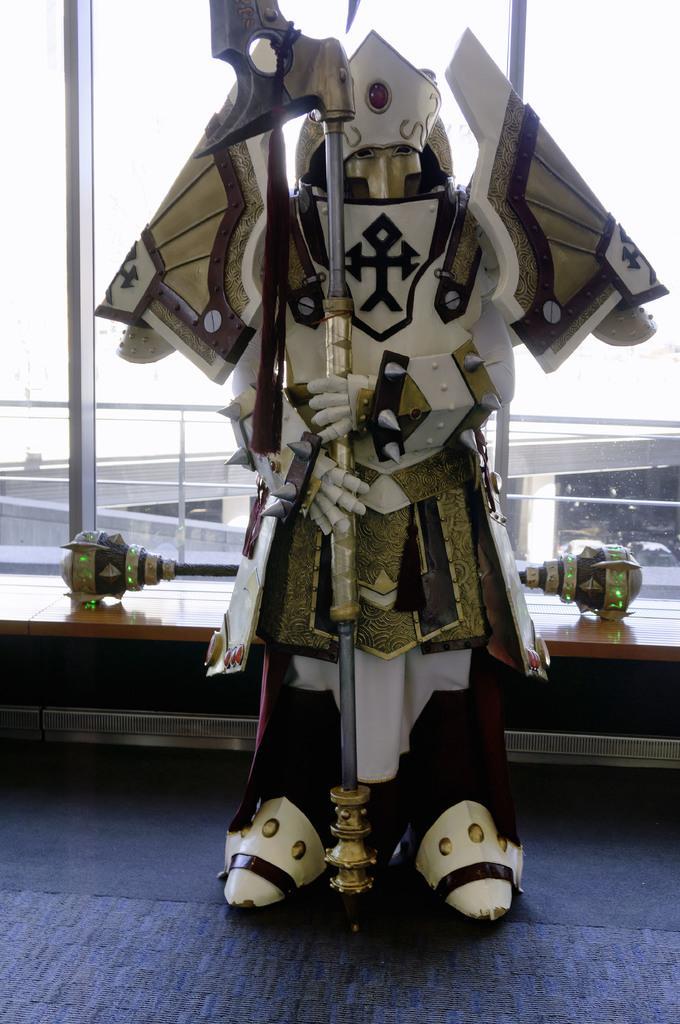How would you summarize this image in a sentence or two? In this image we can see a sculpture on the surface, behind the sculpture there are some objects, in the background, we can see a bridge, pillars and some vehicles. 